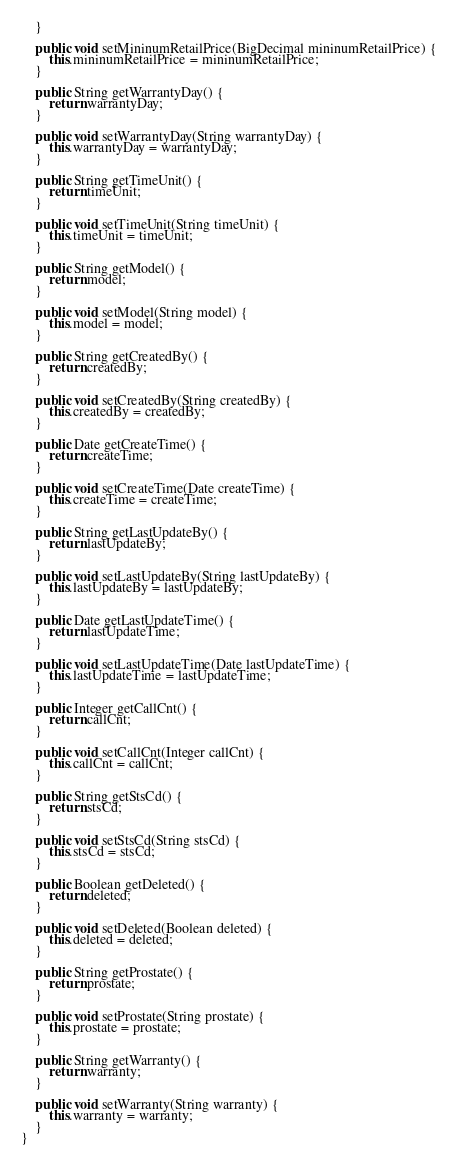<code> <loc_0><loc_0><loc_500><loc_500><_Java_>    }

    public void setMininumRetailPrice(BigDecimal mininumRetailPrice) {
        this.mininumRetailPrice = mininumRetailPrice;
    }

    public String getWarrantyDay() {
        return warrantyDay;
    }

    public void setWarrantyDay(String warrantyDay) {
        this.warrantyDay = warrantyDay;
    }

    public String getTimeUnit() {
        return timeUnit;
    }

    public void setTimeUnit(String timeUnit) {
        this.timeUnit = timeUnit;
    }

    public String getModel() {
        return model;
    }

    public void setModel(String model) {
        this.model = model;
    }

    public String getCreatedBy() {
        return createdBy;
    }

    public void setCreatedBy(String createdBy) {
        this.createdBy = createdBy;
    }

    public Date getCreateTime() {
        return createTime;
    }

    public void setCreateTime(Date createTime) {
        this.createTime = createTime;
    }

    public String getLastUpdateBy() {
        return lastUpdateBy;
    }

    public void setLastUpdateBy(String lastUpdateBy) {
        this.lastUpdateBy = lastUpdateBy;
    }

    public Date getLastUpdateTime() {
        return lastUpdateTime;
    }

    public void setLastUpdateTime(Date lastUpdateTime) {
        this.lastUpdateTime = lastUpdateTime;
    }

    public Integer getCallCnt() {
        return callCnt;
    }

    public void setCallCnt(Integer callCnt) {
        this.callCnt = callCnt;
    }

    public String getStsCd() {
        return stsCd;
    }

    public void setStsCd(String stsCd) {
        this.stsCd = stsCd;
    }

    public Boolean getDeleted() {
        return deleted;
    }

    public void setDeleted(Boolean deleted) {
        this.deleted = deleted;
    }

    public String getProstate() {
        return prostate;
    }

    public void setProstate(String prostate) {
        this.prostate = prostate;
    }

    public String getWarranty() {
        return warranty;
    }

    public void setWarranty(String warranty) {
        this.warranty = warranty;
    }
}
</code> 